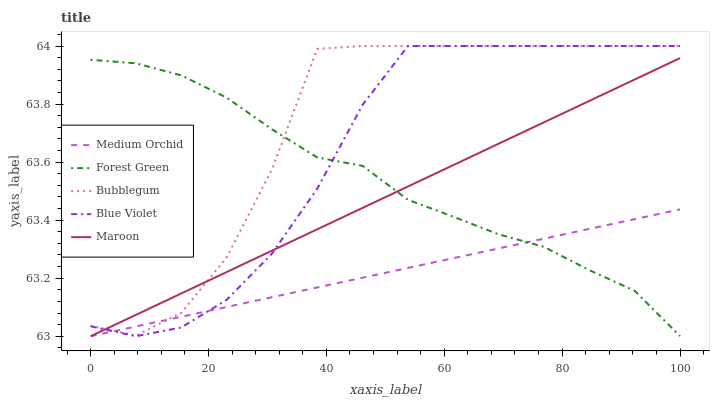Does Medium Orchid have the minimum area under the curve?
Answer yes or no. Yes. Does Bubblegum have the maximum area under the curve?
Answer yes or no. Yes. Does Forest Green have the minimum area under the curve?
Answer yes or no. No. Does Forest Green have the maximum area under the curve?
Answer yes or no. No. Is Medium Orchid the smoothest?
Answer yes or no. Yes. Is Bubblegum the roughest?
Answer yes or no. Yes. Is Forest Green the smoothest?
Answer yes or no. No. Is Forest Green the roughest?
Answer yes or no. No. Does Maroon have the lowest value?
Answer yes or no. Yes. Does Forest Green have the lowest value?
Answer yes or no. No. Does Bubblegum have the highest value?
Answer yes or no. Yes. Does Forest Green have the highest value?
Answer yes or no. No. Does Maroon intersect Forest Green?
Answer yes or no. Yes. Is Maroon less than Forest Green?
Answer yes or no. No. Is Maroon greater than Forest Green?
Answer yes or no. No. 